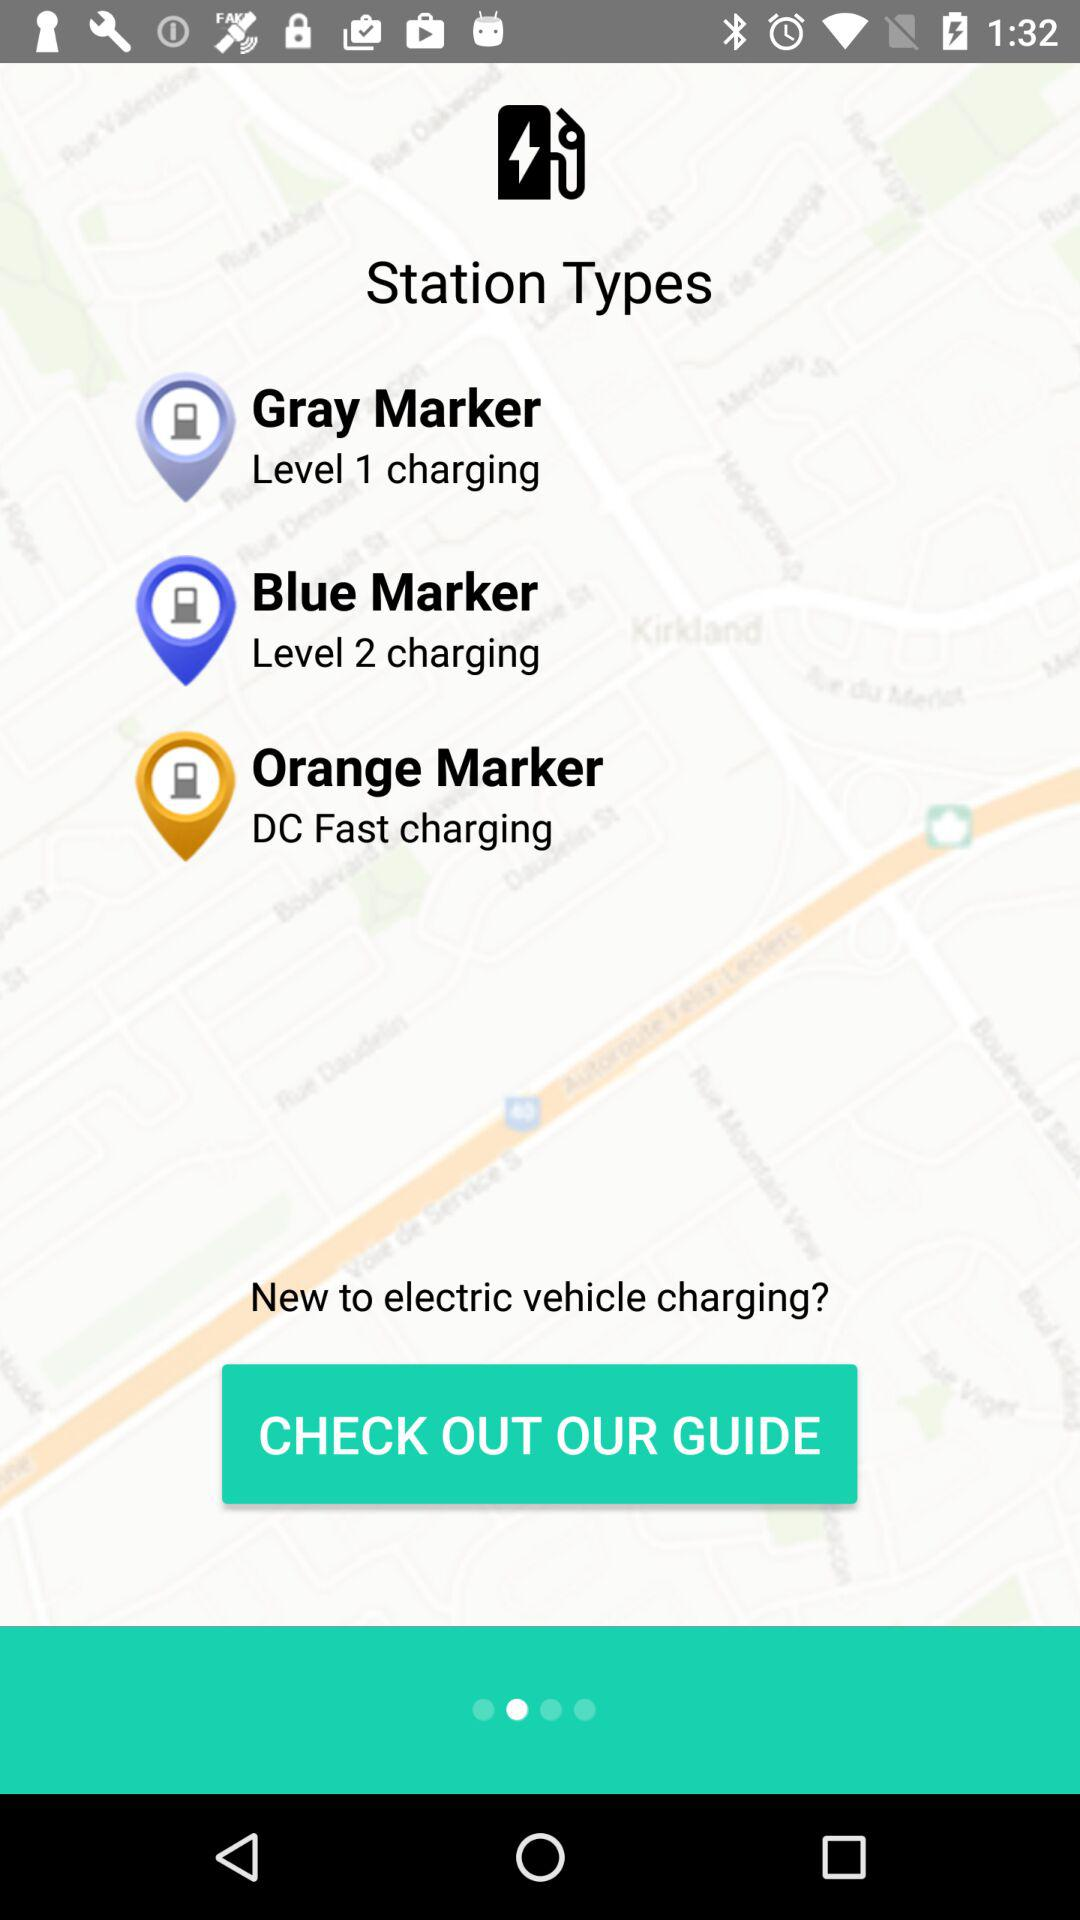How many types of charging stations are there?
Answer the question using a single word or phrase. 3 